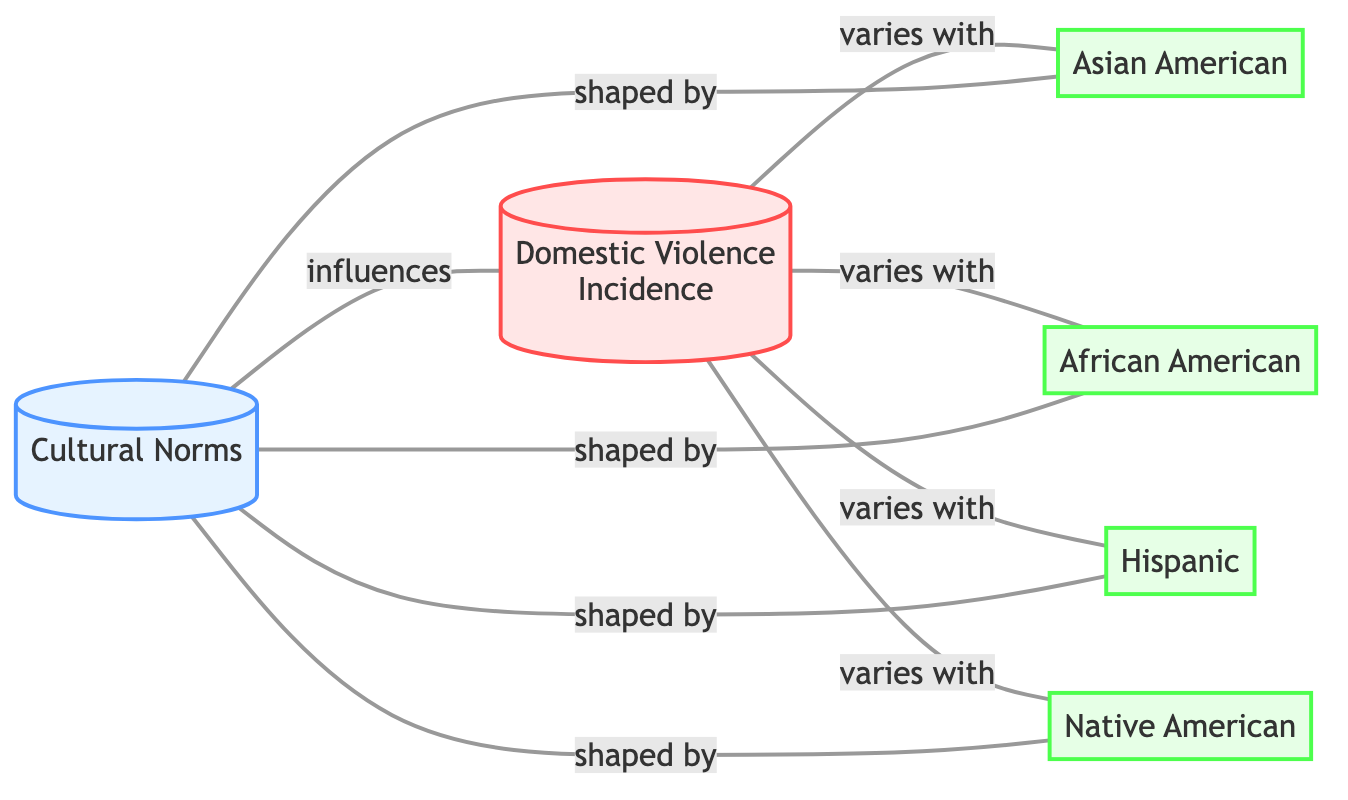What is the total number of nodes in the diagram? The diagram contains six distinct nodes: Cultural Norms, Domestic Violence Incidence, Asian American, African American, Hispanic, and Native American. Therefore, the total is six.
Answer: 6 Which node is labeled 'Cultural Norms'? The node labeled 'Cultural Norms' is shown as the first node in the diagram. It clearly indicates one of the primary concepts in the analysis of domestic violence.
Answer: Cultural Norms How many edges connect to the node 'Domestic Violence Incidence'? The 'Domestic Violence Incidence' node has four edges connecting it to the ethnic groups: Asian American, African American, Hispanic, and Native American, indicating varying relationships.
Answer: 4 What type of relationship is indicated between 'Cultural Norms' and 'Domestic Violence Incidence'? The relationship between 'Cultural Norms' and 'Domestic Violence Incidence' is labeled as "influences," showing that cultural norms have an effect on the incidence of domestic violence.
Answer: influences Which ethnic group is connected to 'Cultural Norms'? The node 'Cultural Norms' is connected to four ethnic groups: Asian American, African American, Hispanic, and Native American through the label "shaped by." This indicates that these cultures impact the norms at play.
Answer: Asian American, African American, Hispanic, Native American How does domestic violence incidence vary? The phrase "varies with" indicates that the domestic violence incidence fluctuates according to the cultural influences of the four ethnic groups, correlating each group with different levels of incidence.
Answer: varies with 